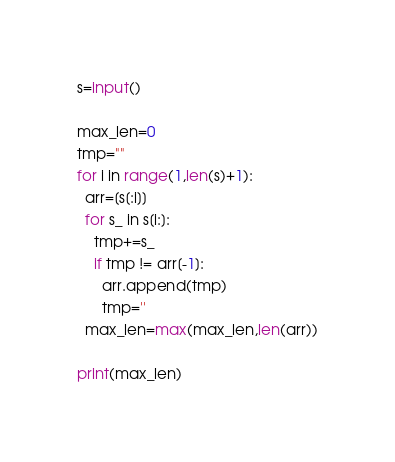<code> <loc_0><loc_0><loc_500><loc_500><_Python_>s=input()

max_len=0
tmp=""
for i in range(1,len(s)+1):
  arr=[s[:i]]
  for s_ in s[i:]:
    tmp+=s_
    if tmp != arr[-1]:
      arr.append(tmp)
      tmp=''
  max_len=max(max_len,len(arr))

print(max_len)</code> 